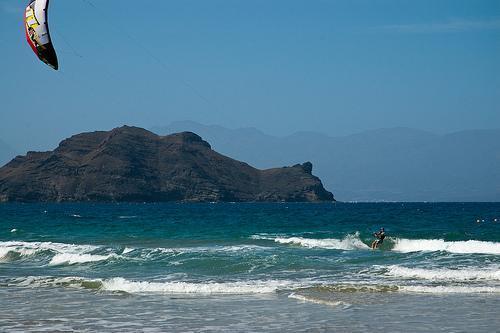How many people are visible?
Give a very brief answer. 1. 